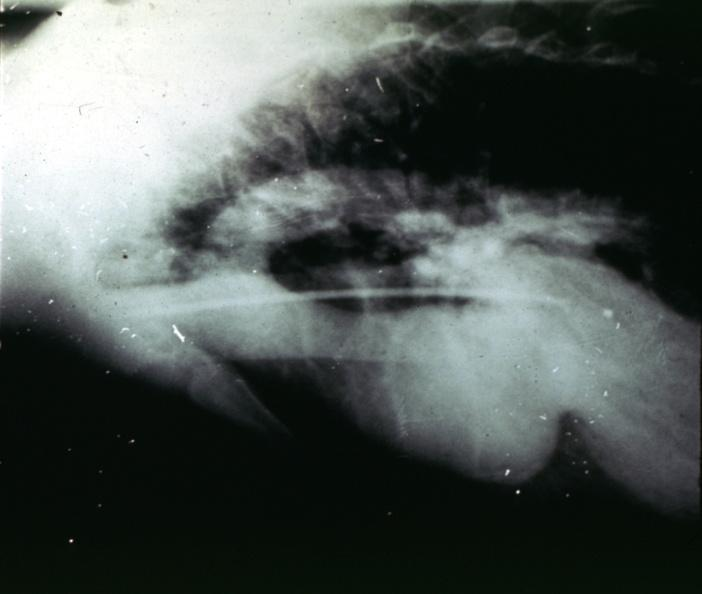what does this image show?
Answer the question using a single word or phrase. Marfans syndrome 